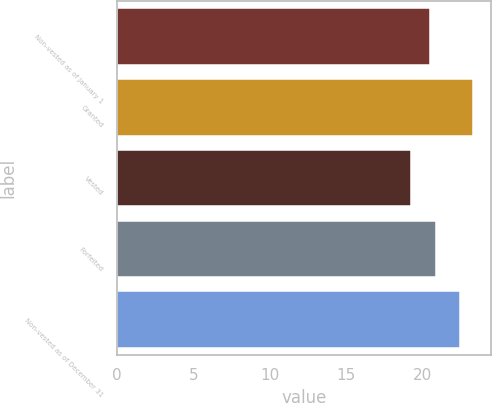Convert chart to OTSL. <chart><loc_0><loc_0><loc_500><loc_500><bar_chart><fcel>Non-vested as of January 1<fcel>Granted<fcel>Vested<fcel>Forfeited<fcel>Non-vested as of December 31<nl><fcel>20.49<fcel>23.33<fcel>19.27<fcel>20.9<fcel>22.52<nl></chart> 